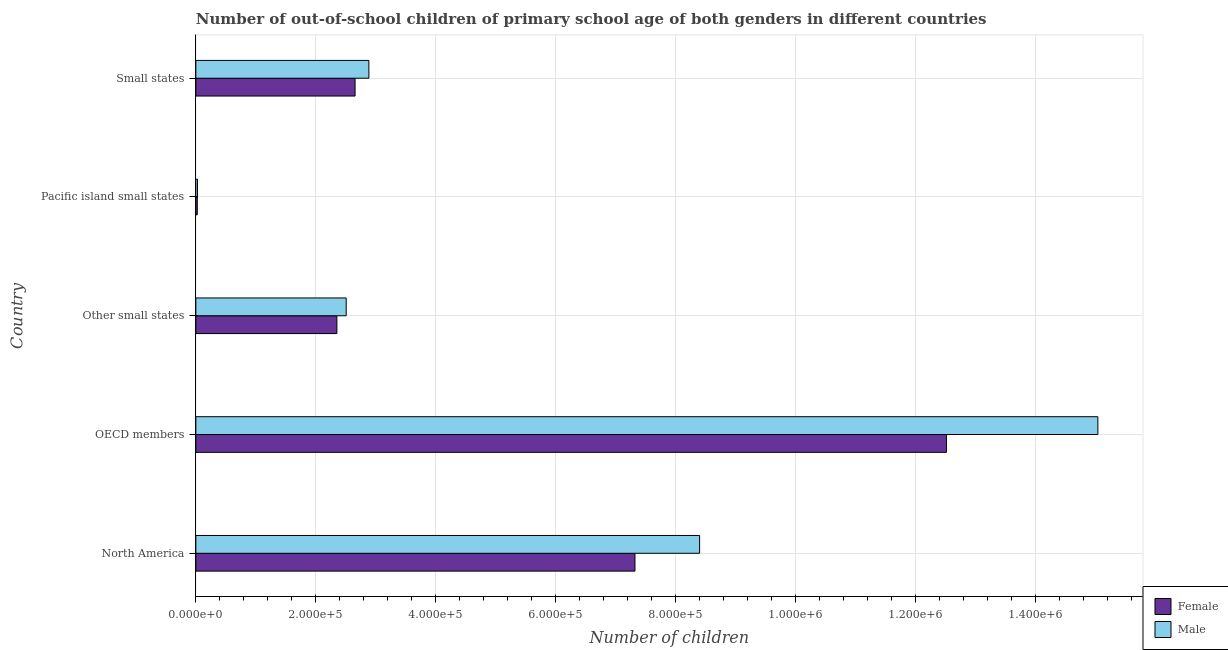How many groups of bars are there?
Your answer should be very brief. 5. Are the number of bars per tick equal to the number of legend labels?
Keep it short and to the point. Yes. Are the number of bars on each tick of the Y-axis equal?
Your answer should be very brief. Yes. How many bars are there on the 2nd tick from the bottom?
Your answer should be compact. 2. What is the label of the 1st group of bars from the top?
Ensure brevity in your answer.  Small states. What is the number of male out-of-school students in Small states?
Give a very brief answer. 2.89e+05. Across all countries, what is the maximum number of male out-of-school students?
Make the answer very short. 1.50e+06. Across all countries, what is the minimum number of female out-of-school students?
Your response must be concise. 2454. In which country was the number of female out-of-school students maximum?
Your answer should be very brief. OECD members. In which country was the number of female out-of-school students minimum?
Ensure brevity in your answer.  Pacific island small states. What is the total number of female out-of-school students in the graph?
Your answer should be compact. 2.49e+06. What is the difference between the number of male out-of-school students in Other small states and that in Small states?
Provide a short and direct response. -3.78e+04. What is the difference between the number of female out-of-school students in Pacific island small states and the number of male out-of-school students in OECD members?
Provide a short and direct response. -1.50e+06. What is the average number of male out-of-school students per country?
Provide a succinct answer. 5.77e+05. What is the difference between the number of male out-of-school students and number of female out-of-school students in OECD members?
Offer a terse response. 2.52e+05. In how many countries, is the number of female out-of-school students greater than 1400000 ?
Your answer should be compact. 0. What is the ratio of the number of female out-of-school students in OECD members to that in Small states?
Offer a terse response. 4.71. Is the number of male out-of-school students in OECD members less than that in Pacific island small states?
Offer a very short reply. No. What is the difference between the highest and the second highest number of male out-of-school students?
Your answer should be compact. 6.64e+05. What is the difference between the highest and the lowest number of male out-of-school students?
Your answer should be compact. 1.50e+06. Is the sum of the number of female out-of-school students in Other small states and Small states greater than the maximum number of male out-of-school students across all countries?
Keep it short and to the point. No. What does the 2nd bar from the top in Other small states represents?
Ensure brevity in your answer.  Female. What does the 1st bar from the bottom in OECD members represents?
Make the answer very short. Female. How many bars are there?
Your answer should be compact. 10. Are all the bars in the graph horizontal?
Provide a succinct answer. Yes. What is the difference between two consecutive major ticks on the X-axis?
Provide a succinct answer. 2.00e+05. Are the values on the major ticks of X-axis written in scientific E-notation?
Provide a short and direct response. Yes. Does the graph contain any zero values?
Make the answer very short. No. Where does the legend appear in the graph?
Your response must be concise. Bottom right. How many legend labels are there?
Provide a short and direct response. 2. How are the legend labels stacked?
Offer a terse response. Vertical. What is the title of the graph?
Give a very brief answer. Number of out-of-school children of primary school age of both genders in different countries. What is the label or title of the X-axis?
Offer a terse response. Number of children. What is the label or title of the Y-axis?
Offer a very short reply. Country. What is the Number of children in Female in North America?
Provide a short and direct response. 7.32e+05. What is the Number of children in Male in North America?
Your response must be concise. 8.40e+05. What is the Number of children of Female in OECD members?
Provide a succinct answer. 1.25e+06. What is the Number of children of Male in OECD members?
Provide a succinct answer. 1.50e+06. What is the Number of children of Female in Other small states?
Your answer should be very brief. 2.35e+05. What is the Number of children in Male in Other small states?
Offer a very short reply. 2.51e+05. What is the Number of children in Female in Pacific island small states?
Provide a short and direct response. 2454. What is the Number of children of Male in Pacific island small states?
Provide a short and direct response. 2758. What is the Number of children in Female in Small states?
Give a very brief answer. 2.66e+05. What is the Number of children in Male in Small states?
Offer a very short reply. 2.89e+05. Across all countries, what is the maximum Number of children of Female?
Provide a succinct answer. 1.25e+06. Across all countries, what is the maximum Number of children in Male?
Your answer should be compact. 1.50e+06. Across all countries, what is the minimum Number of children in Female?
Offer a very short reply. 2454. Across all countries, what is the minimum Number of children in Male?
Keep it short and to the point. 2758. What is the total Number of children of Female in the graph?
Ensure brevity in your answer.  2.49e+06. What is the total Number of children of Male in the graph?
Ensure brevity in your answer.  2.89e+06. What is the difference between the Number of children in Female in North America and that in OECD members?
Offer a terse response. -5.19e+05. What is the difference between the Number of children of Male in North America and that in OECD members?
Offer a very short reply. -6.64e+05. What is the difference between the Number of children in Female in North America and that in Other small states?
Your response must be concise. 4.97e+05. What is the difference between the Number of children of Male in North America and that in Other small states?
Provide a short and direct response. 5.89e+05. What is the difference between the Number of children in Female in North America and that in Pacific island small states?
Provide a succinct answer. 7.30e+05. What is the difference between the Number of children in Male in North America and that in Pacific island small states?
Offer a terse response. 8.37e+05. What is the difference between the Number of children in Female in North America and that in Small states?
Keep it short and to the point. 4.67e+05. What is the difference between the Number of children of Male in North America and that in Small states?
Your response must be concise. 5.52e+05. What is the difference between the Number of children of Female in OECD members and that in Other small states?
Provide a succinct answer. 1.02e+06. What is the difference between the Number of children of Male in OECD members and that in Other small states?
Keep it short and to the point. 1.25e+06. What is the difference between the Number of children in Female in OECD members and that in Pacific island small states?
Make the answer very short. 1.25e+06. What is the difference between the Number of children of Male in OECD members and that in Pacific island small states?
Ensure brevity in your answer.  1.50e+06. What is the difference between the Number of children in Female in OECD members and that in Small states?
Ensure brevity in your answer.  9.86e+05. What is the difference between the Number of children of Male in OECD members and that in Small states?
Your response must be concise. 1.22e+06. What is the difference between the Number of children in Female in Other small states and that in Pacific island small states?
Offer a very short reply. 2.33e+05. What is the difference between the Number of children in Male in Other small states and that in Pacific island small states?
Offer a very short reply. 2.48e+05. What is the difference between the Number of children of Female in Other small states and that in Small states?
Make the answer very short. -3.03e+04. What is the difference between the Number of children in Male in Other small states and that in Small states?
Give a very brief answer. -3.78e+04. What is the difference between the Number of children of Female in Pacific island small states and that in Small states?
Keep it short and to the point. -2.63e+05. What is the difference between the Number of children of Male in Pacific island small states and that in Small states?
Your answer should be compact. -2.86e+05. What is the difference between the Number of children of Female in North America and the Number of children of Male in OECD members?
Offer a terse response. -7.72e+05. What is the difference between the Number of children in Female in North America and the Number of children in Male in Other small states?
Your answer should be very brief. 4.82e+05. What is the difference between the Number of children of Female in North America and the Number of children of Male in Pacific island small states?
Provide a short and direct response. 7.30e+05. What is the difference between the Number of children of Female in North America and the Number of children of Male in Small states?
Your response must be concise. 4.44e+05. What is the difference between the Number of children of Female in OECD members and the Number of children of Male in Other small states?
Your response must be concise. 1.00e+06. What is the difference between the Number of children of Female in OECD members and the Number of children of Male in Pacific island small states?
Provide a short and direct response. 1.25e+06. What is the difference between the Number of children in Female in OECD members and the Number of children in Male in Small states?
Offer a terse response. 9.63e+05. What is the difference between the Number of children of Female in Other small states and the Number of children of Male in Pacific island small states?
Give a very brief answer. 2.32e+05. What is the difference between the Number of children of Female in Other small states and the Number of children of Male in Small states?
Your answer should be compact. -5.33e+04. What is the difference between the Number of children of Female in Pacific island small states and the Number of children of Male in Small states?
Your response must be concise. -2.86e+05. What is the average Number of children of Female per country?
Offer a terse response. 4.97e+05. What is the average Number of children in Male per country?
Keep it short and to the point. 5.77e+05. What is the difference between the Number of children of Female and Number of children of Male in North America?
Your answer should be compact. -1.08e+05. What is the difference between the Number of children of Female and Number of children of Male in OECD members?
Provide a succinct answer. -2.52e+05. What is the difference between the Number of children in Female and Number of children in Male in Other small states?
Keep it short and to the point. -1.55e+04. What is the difference between the Number of children in Female and Number of children in Male in Pacific island small states?
Your answer should be compact. -304. What is the difference between the Number of children of Female and Number of children of Male in Small states?
Give a very brief answer. -2.30e+04. What is the ratio of the Number of children in Female in North America to that in OECD members?
Make the answer very short. 0.58. What is the ratio of the Number of children of Male in North America to that in OECD members?
Provide a succinct answer. 0.56. What is the ratio of the Number of children of Female in North America to that in Other small states?
Provide a succinct answer. 3.11. What is the ratio of the Number of children in Male in North America to that in Other small states?
Make the answer very short. 3.35. What is the ratio of the Number of children in Female in North America to that in Pacific island small states?
Give a very brief answer. 298.4. What is the ratio of the Number of children of Male in North America to that in Pacific island small states?
Your response must be concise. 304.59. What is the ratio of the Number of children in Female in North America to that in Small states?
Your answer should be compact. 2.76. What is the ratio of the Number of children of Male in North America to that in Small states?
Provide a short and direct response. 2.91. What is the ratio of the Number of children in Female in OECD members to that in Other small states?
Offer a terse response. 5.32. What is the ratio of the Number of children of Male in OECD members to that in Other small states?
Give a very brief answer. 6. What is the ratio of the Number of children in Female in OECD members to that in Pacific island small states?
Make the answer very short. 510.09. What is the ratio of the Number of children in Male in OECD members to that in Pacific island small states?
Keep it short and to the point. 545.39. What is the ratio of the Number of children of Female in OECD members to that in Small states?
Keep it short and to the point. 4.71. What is the ratio of the Number of children in Male in OECD members to that in Small states?
Your answer should be compact. 5.21. What is the ratio of the Number of children in Female in Other small states to that in Pacific island small states?
Your response must be concise. 95.86. What is the ratio of the Number of children in Male in Other small states to that in Pacific island small states?
Offer a very short reply. 90.92. What is the ratio of the Number of children of Female in Other small states to that in Small states?
Give a very brief answer. 0.89. What is the ratio of the Number of children of Male in Other small states to that in Small states?
Keep it short and to the point. 0.87. What is the ratio of the Number of children of Female in Pacific island small states to that in Small states?
Make the answer very short. 0.01. What is the ratio of the Number of children in Male in Pacific island small states to that in Small states?
Your answer should be very brief. 0.01. What is the difference between the highest and the second highest Number of children in Female?
Make the answer very short. 5.19e+05. What is the difference between the highest and the second highest Number of children in Male?
Make the answer very short. 6.64e+05. What is the difference between the highest and the lowest Number of children in Female?
Ensure brevity in your answer.  1.25e+06. What is the difference between the highest and the lowest Number of children of Male?
Provide a succinct answer. 1.50e+06. 